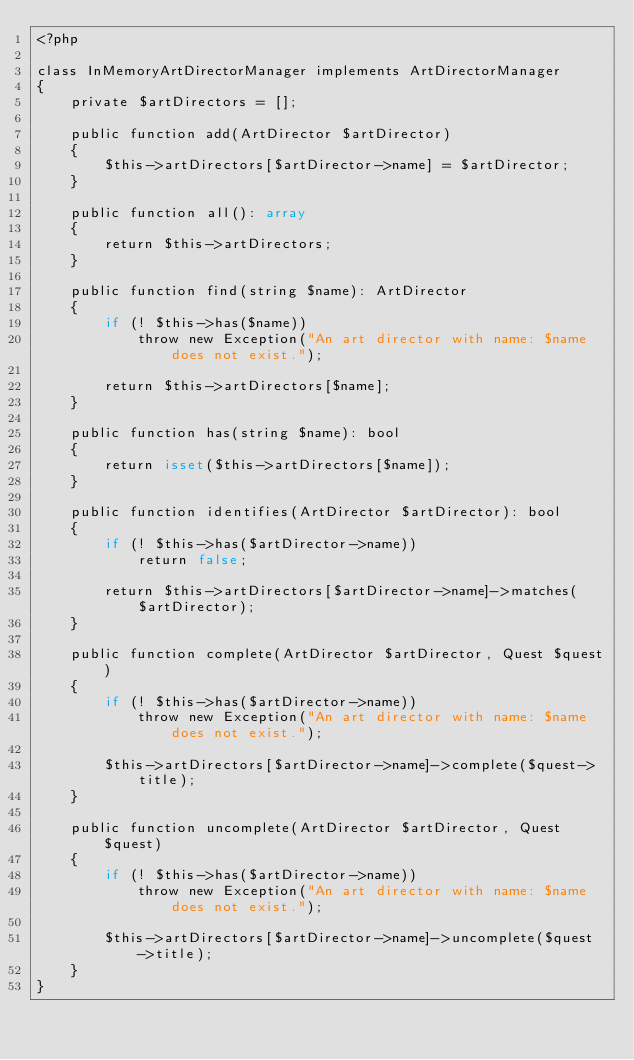Convert code to text. <code><loc_0><loc_0><loc_500><loc_500><_PHP_><?php

class InMemoryArtDirectorManager implements ArtDirectorManager
{
    private $artDirectors = [];

    public function add(ArtDirector $artDirector)
    {
        $this->artDirectors[$artDirector->name] = $artDirector;
    }

    public function all(): array
    {
        return $this->artDirectors;
    }

    public function find(string $name): ArtDirector
    {
        if (! $this->has($name))
            throw new Exception("An art director with name: $name does not exist.");

        return $this->artDirectors[$name];
    }

    public function has(string $name): bool
    {
        return isset($this->artDirectors[$name]);
    }

    public function identifies(ArtDirector $artDirector): bool
    {
        if (! $this->has($artDirector->name))
            return false;

        return $this->artDirectors[$artDirector->name]->matches($artDirector);
    }

    public function complete(ArtDirector $artDirector, Quest $quest)
    {
        if (! $this->has($artDirector->name))
            throw new Exception("An art director with name: $name does not exist.");

        $this->artDirectors[$artDirector->name]->complete($quest->title);
    }

    public function uncomplete(ArtDirector $artDirector, Quest $quest)
    {
        if (! $this->has($artDirector->name))
            throw new Exception("An art director with name: $name does not exist.");

        $this->artDirectors[$artDirector->name]->uncomplete($quest->title);
    }
}</code> 